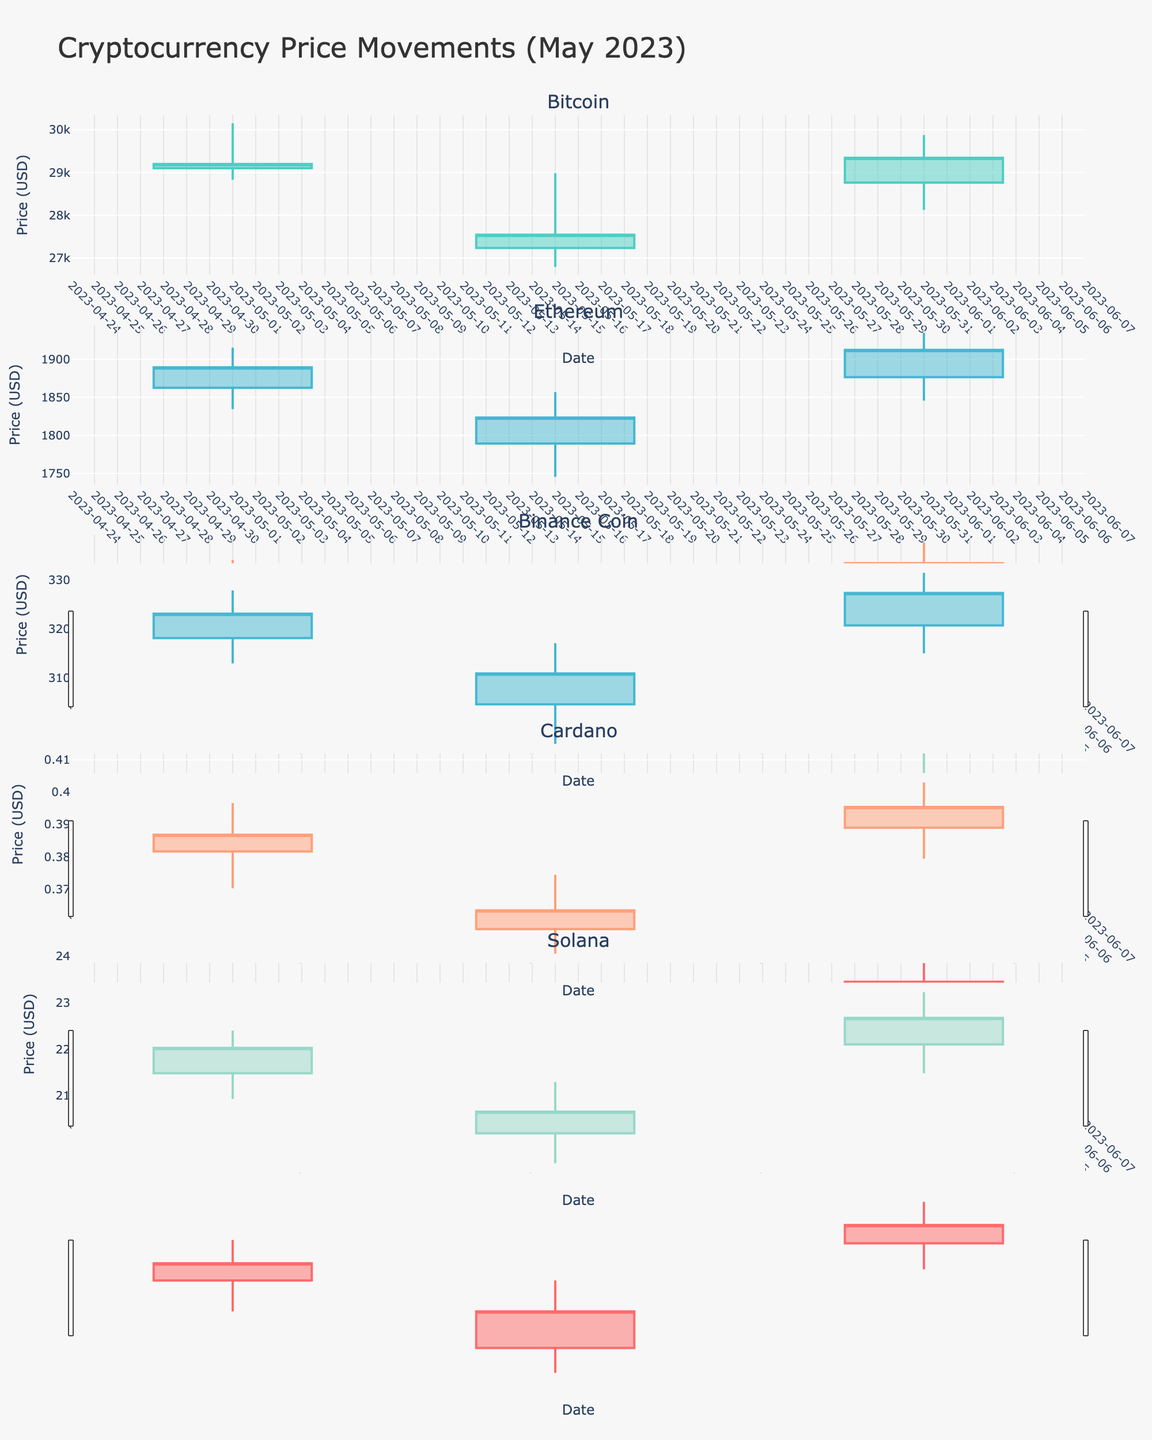What's the title of the chart? The title of the chart is located at the top of the figure. It reads "Cryptocurrency Price Movements (May 2023)," indicating that the chart displays the price movements of various cryptocurrencies for the specified month.
Answer: Cryptocurrency Price Movements (May 2023) How many different cryptocurrencies are displayed in the chart? Each subplot represents a different cryptocurrency, and each subplot title corresponds to one. By counting these titles, we see there are 5 different cryptocurrencies displayed: Bitcoin, Ethereum, Binance Coin, Cardano, and Solana.
Answer: 5 Which cryptocurrency showed the highest closing price? By examining the highest closing points in the last bar of each candlestick plot, we can see that Bitcoin had the highest closing price among all cryptocurrencies in the month of May 2023.
Answer: Bitcoin For Cardano, what is the difference between the highest high and the lowest low in May 2023? Cardano's highest high is shown around $0.4123 and the lowest low is shown around $0.3678. The difference is calculated as $0.4123 - $0.3678.
Answer: $0.0445 Which cryptocurrency showed the most significant volatility in May 2023? Volatility can be assessed by the range between highs and lows. By visually comparing these ranges in each subplot, Bitcoin seems to have the largest range, indicating the most significant volatility.
Answer: Bitcoin How did Ethereum's closing price change from May 1 to May 31? Referring to the subplot for Ethereum, the closing price on May 1 is around $1889.34 and on May 31 is around $1912.34. The change is calculated as $1912.34 - $1889.34.
Answer: $23.00 Which cryptocurrency had a decreasing trend in May 2023? A decreasing trend can be observed by a downward movement in the candles over the entire month. By comparing the opening price on May 1st and the closing price on May 31st for each cryptocurrency, it can be seen that Binance Coin had a decrease from $325.78 to $328.67 to $315.67.
Answer: Binance Coin What was the closing price of Solana on May 15, 2023? Looking at the data points for Solana on May 15th in its respective subplot, the closing price can be identified.
Answer: $21.89 Compare the closing prices of Bitcoin and Ethereum on May 31, 2023. Which one is higher? By examining the closing prices of both Bitcoin and Ethereum subplots on May 31, Bitcoin closed around $29345.67, while Ethereum closed around $1912.34.
Answer: Bitcoin 